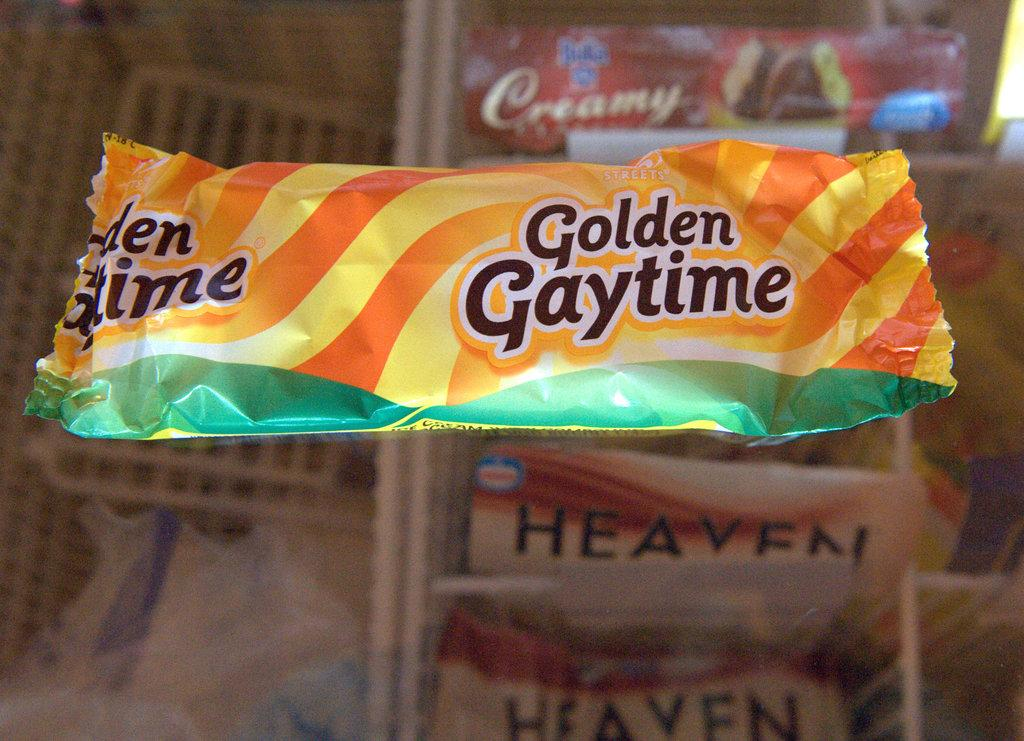What is on the cover that is visible in the image? There is a cover with text in the image. Where is the cover located in the image? The cover is placed on a surface in the image. What can be seen in the background of the image? There are boxes and bags in the background of the image. How are the boxes and bags arranged in the image? The boxes and bags are placed on racks in the image. How many giants are visible in the image? There are no giants present in the image. What fact can be learned about the store from the image? The image does not show a store, so no fact about a store can be learned from it. 